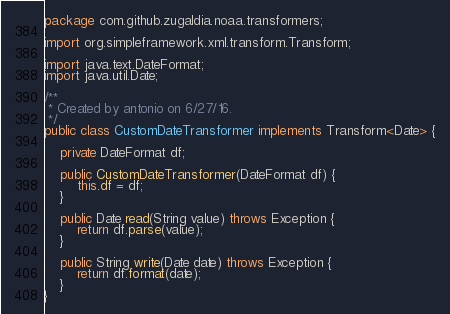Convert code to text. <code><loc_0><loc_0><loc_500><loc_500><_Java_>package com.github.zugaldia.noaa.transformers;

import org.simpleframework.xml.transform.Transform;

import java.text.DateFormat;
import java.util.Date;

/**
 * Created by antonio on 6/27/16.
 */
public class CustomDateTransformer implements Transform<Date> {

    private DateFormat df;

    public CustomDateTransformer(DateFormat df) {
        this.df = df;
    }

    public Date read(String value) throws Exception {
        return df.parse(value);
    }

    public String write(Date date) throws Exception {
        return df.format(date);
    }
}
</code> 